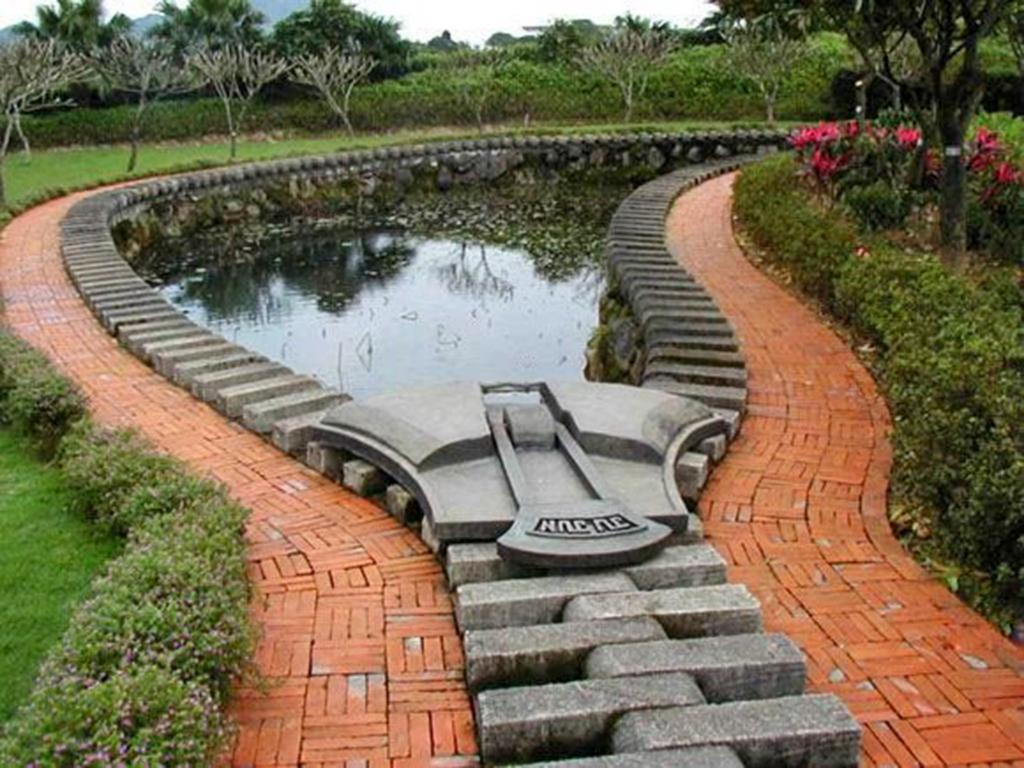What type of vegetation can be seen in the image? There are plants, grass, flowers, and trees visible in the image. What type of terrain is present in the image? There are bricks, mountains, and water visible in the image. What part of the natural environment is visible in the image? The sky is visible in the image. What month is being offered in the image? There is no month being offered in the image; it is a visual representation of various natural elements. Is the image a work of fiction or non-fiction? The image itself is not fiction or non-fiction; it is a photograph or illustration of various natural elements. 